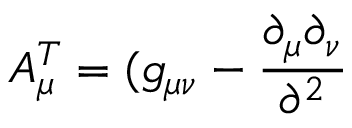<formula> <loc_0><loc_0><loc_500><loc_500>A _ { \mu } ^ { T } = ( g _ { \mu \nu } - \frac { \partial _ { \mu } \partial _ { \nu } } { \partial ^ { 2 } }</formula> 